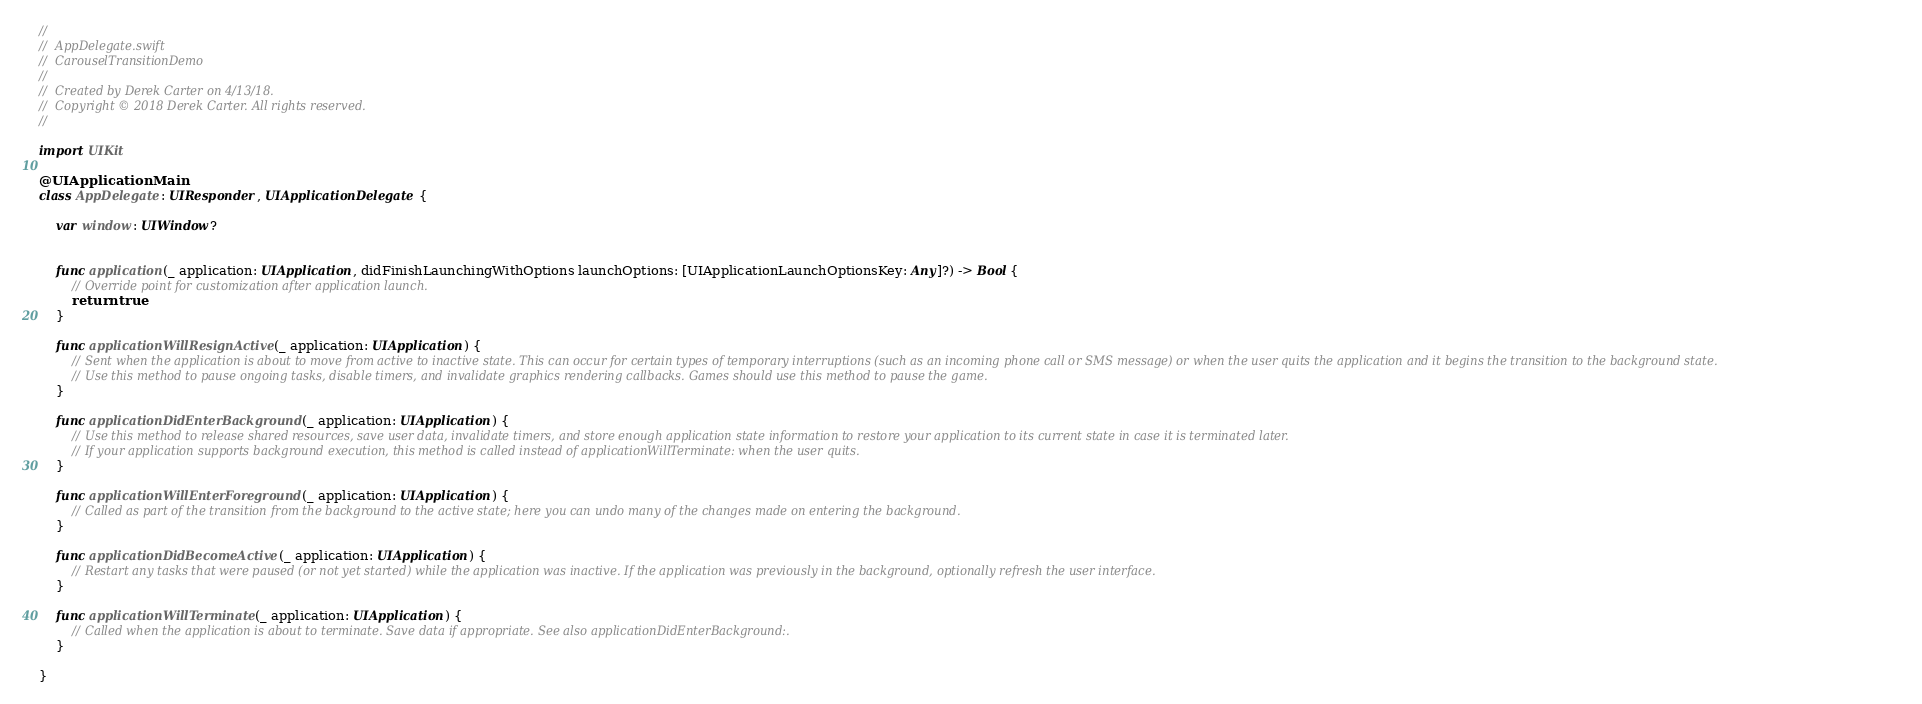Convert code to text. <code><loc_0><loc_0><loc_500><loc_500><_Swift_>//
//  AppDelegate.swift
//  CarouselTransitionDemo
//
//  Created by Derek Carter on 4/13/18.
//  Copyright © 2018 Derek Carter. All rights reserved.
//

import UIKit

@UIApplicationMain
class AppDelegate: UIResponder, UIApplicationDelegate {
    
    var window: UIWindow?
    
    
    func application(_ application: UIApplication, didFinishLaunchingWithOptions launchOptions: [UIApplicationLaunchOptionsKey: Any]?) -> Bool {
        // Override point for customization after application launch.
        return true
    }
    
    func applicationWillResignActive(_ application: UIApplication) {
        // Sent when the application is about to move from active to inactive state. This can occur for certain types of temporary interruptions (such as an incoming phone call or SMS message) or when the user quits the application and it begins the transition to the background state.
        // Use this method to pause ongoing tasks, disable timers, and invalidate graphics rendering callbacks. Games should use this method to pause the game.
    }
    
    func applicationDidEnterBackground(_ application: UIApplication) {
        // Use this method to release shared resources, save user data, invalidate timers, and store enough application state information to restore your application to its current state in case it is terminated later.
        // If your application supports background execution, this method is called instead of applicationWillTerminate: when the user quits.
    }
    
    func applicationWillEnterForeground(_ application: UIApplication) {
        // Called as part of the transition from the background to the active state; here you can undo many of the changes made on entering the background.
    }
    
    func applicationDidBecomeActive(_ application: UIApplication) {
        // Restart any tasks that were paused (or not yet started) while the application was inactive. If the application was previously in the background, optionally refresh the user interface.
    }
    
    func applicationWillTerminate(_ application: UIApplication) {
        // Called when the application is about to terminate. Save data if appropriate. See also applicationDidEnterBackground:.
    }
    
}
</code> 